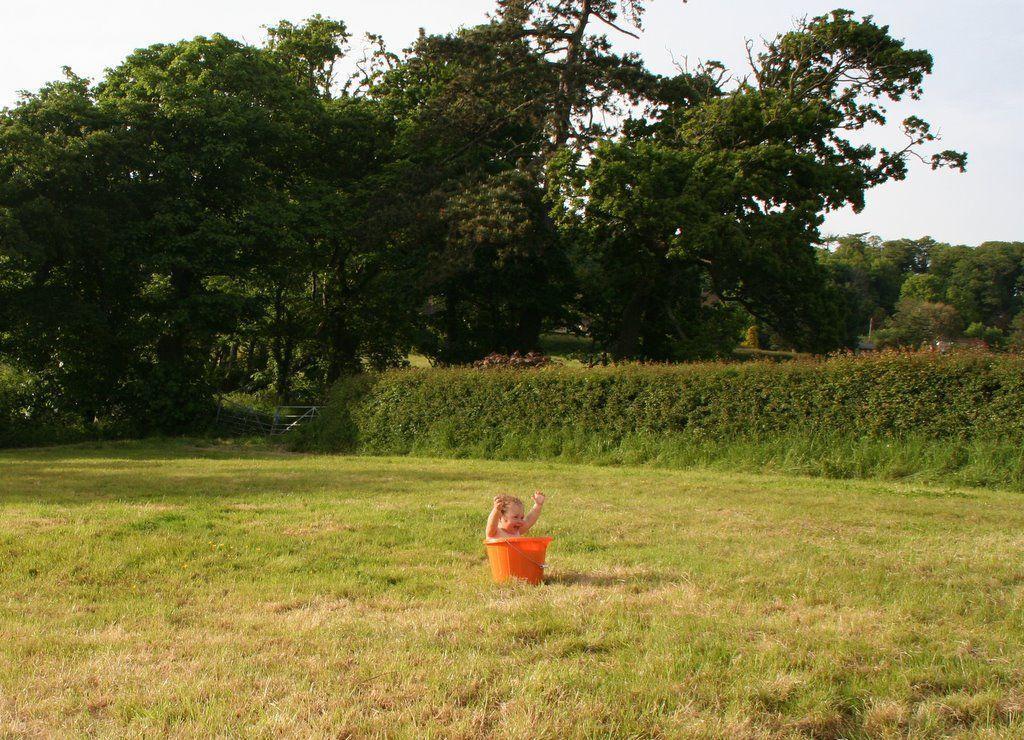In one or two sentences, can you explain what this image depicts? In this image in the center there is one bucket, and in the bucket there is one baby. At the bottom of the image there is grass, and in the background there are some trees and plants. At the top there is sky. 